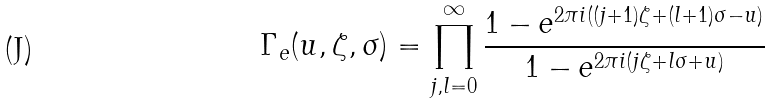<formula> <loc_0><loc_0><loc_500><loc_500>\Gamma _ { e } ( u , \zeta , \sigma ) = \prod _ { j , l = 0 } ^ { \infty } \frac { 1 - e ^ { 2 \pi i ( ( j + 1 ) \zeta + ( l + 1 ) \sigma - u ) } } { 1 - e ^ { 2 \pi i ( j \zeta + l \sigma + u ) } }</formula> 